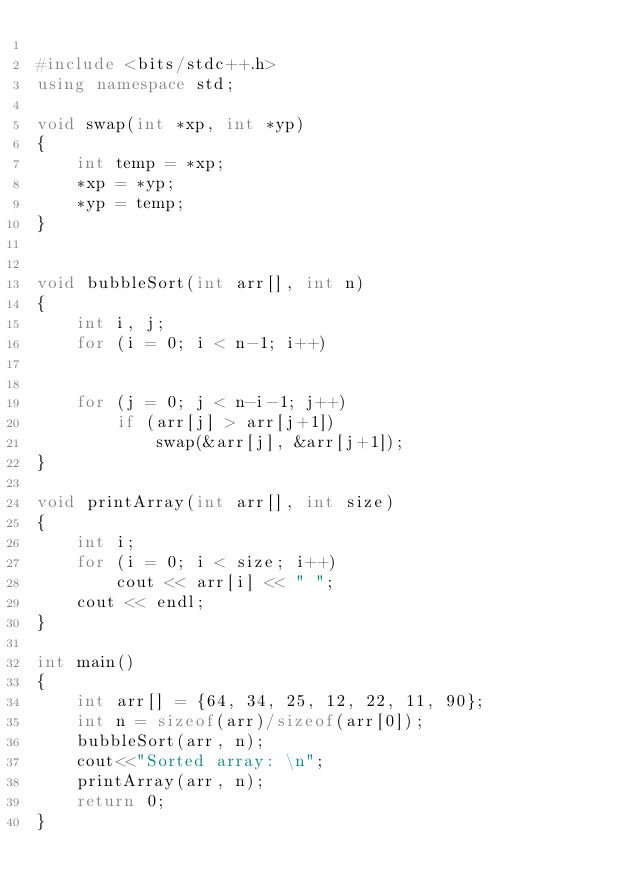<code> <loc_0><loc_0><loc_500><loc_500><_C++_>
#include <bits/stdc++.h>
using namespace std;

void swap(int *xp, int *yp)
{
	int temp = *xp;
	*xp = *yp;
	*yp = temp;
}


void bubbleSort(int arr[], int n)
{
	int i, j;
	for (i = 0; i < n-1; i++)	
	

	for (j = 0; j < n-i-1; j++)
		if (arr[j] > arr[j+1])
			swap(&arr[j], &arr[j+1]);
}

void printArray(int arr[], int size)
{
	int i;
	for (i = 0; i < size; i++)
		cout << arr[i] << " ";
	cout << endl;
}

int main()
{
	int arr[] = {64, 34, 25, 12, 22, 11, 90};
	int n = sizeof(arr)/sizeof(arr[0]);
	bubbleSort(arr, n);
	cout<<"Sorted array: \n";
	printArray(arr, n);
	return 0;
}

</code> 